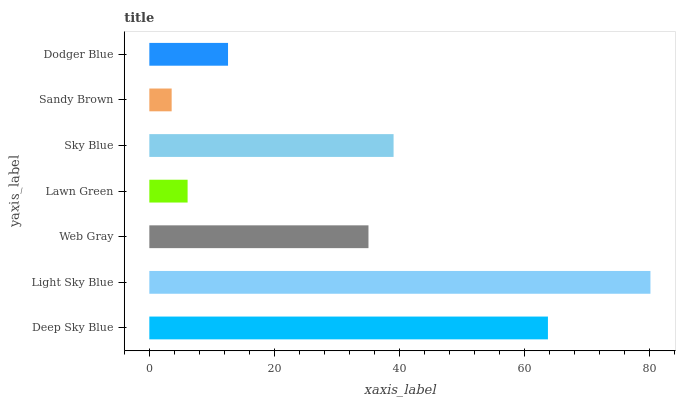Is Sandy Brown the minimum?
Answer yes or no. Yes. Is Light Sky Blue the maximum?
Answer yes or no. Yes. Is Web Gray the minimum?
Answer yes or no. No. Is Web Gray the maximum?
Answer yes or no. No. Is Light Sky Blue greater than Web Gray?
Answer yes or no. Yes. Is Web Gray less than Light Sky Blue?
Answer yes or no. Yes. Is Web Gray greater than Light Sky Blue?
Answer yes or no. No. Is Light Sky Blue less than Web Gray?
Answer yes or no. No. Is Web Gray the high median?
Answer yes or no. Yes. Is Web Gray the low median?
Answer yes or no. Yes. Is Deep Sky Blue the high median?
Answer yes or no. No. Is Deep Sky Blue the low median?
Answer yes or no. No. 